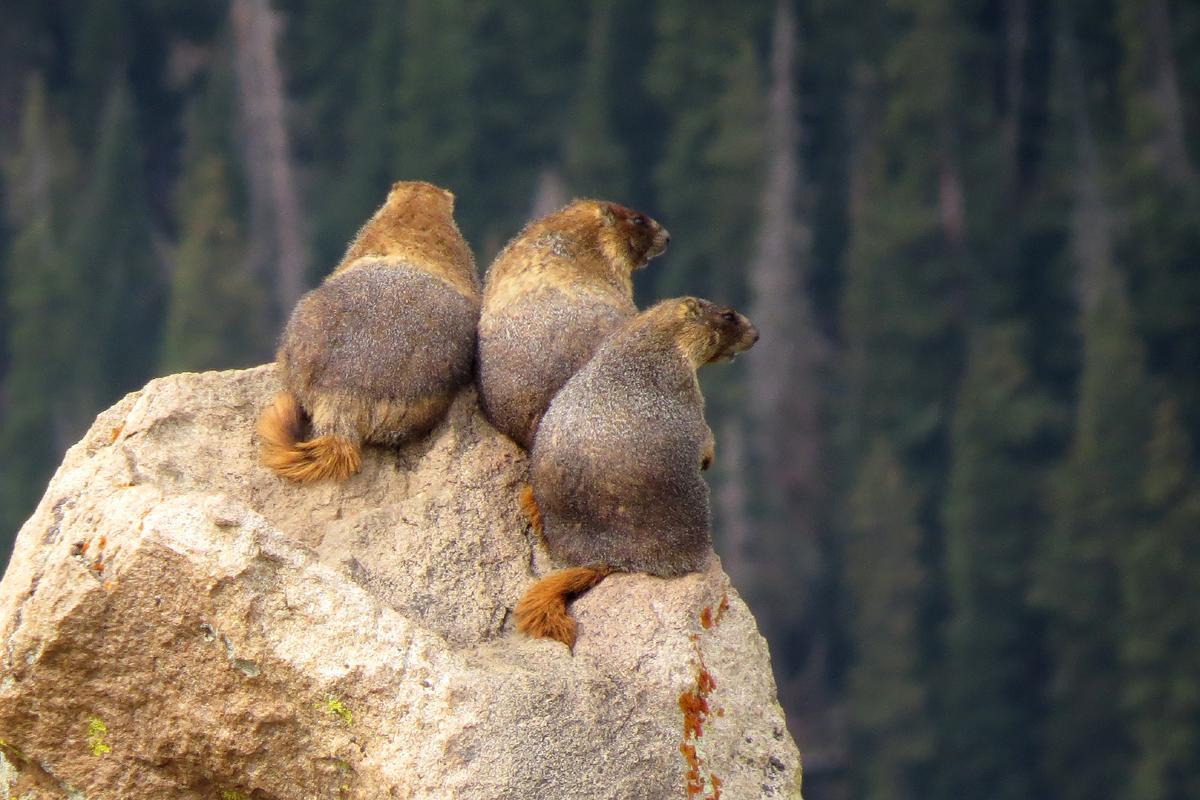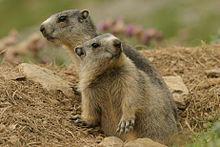The first image is the image on the left, the second image is the image on the right. For the images shown, is this caption "There are two marmots in the right image, and three on the left" true? Answer yes or no. Yes. 